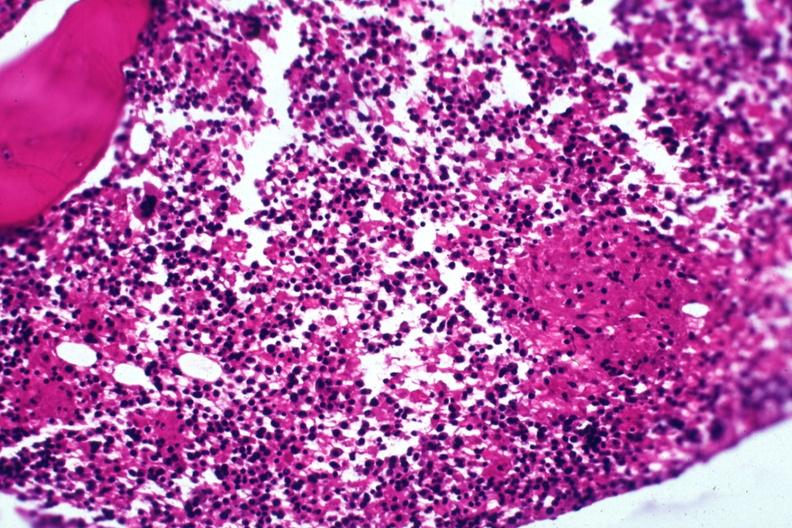what is present?
Answer the question using a single word or phrase. Miliary tuberculosis 